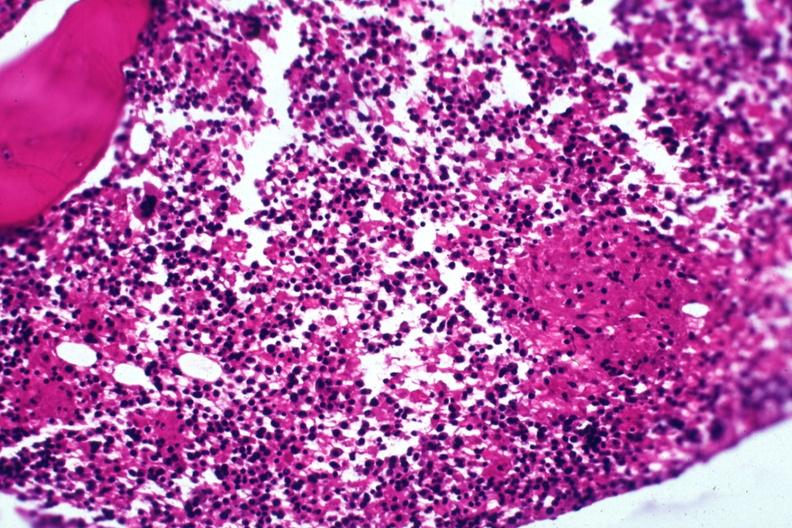what is present?
Answer the question using a single word or phrase. Miliary tuberculosis 